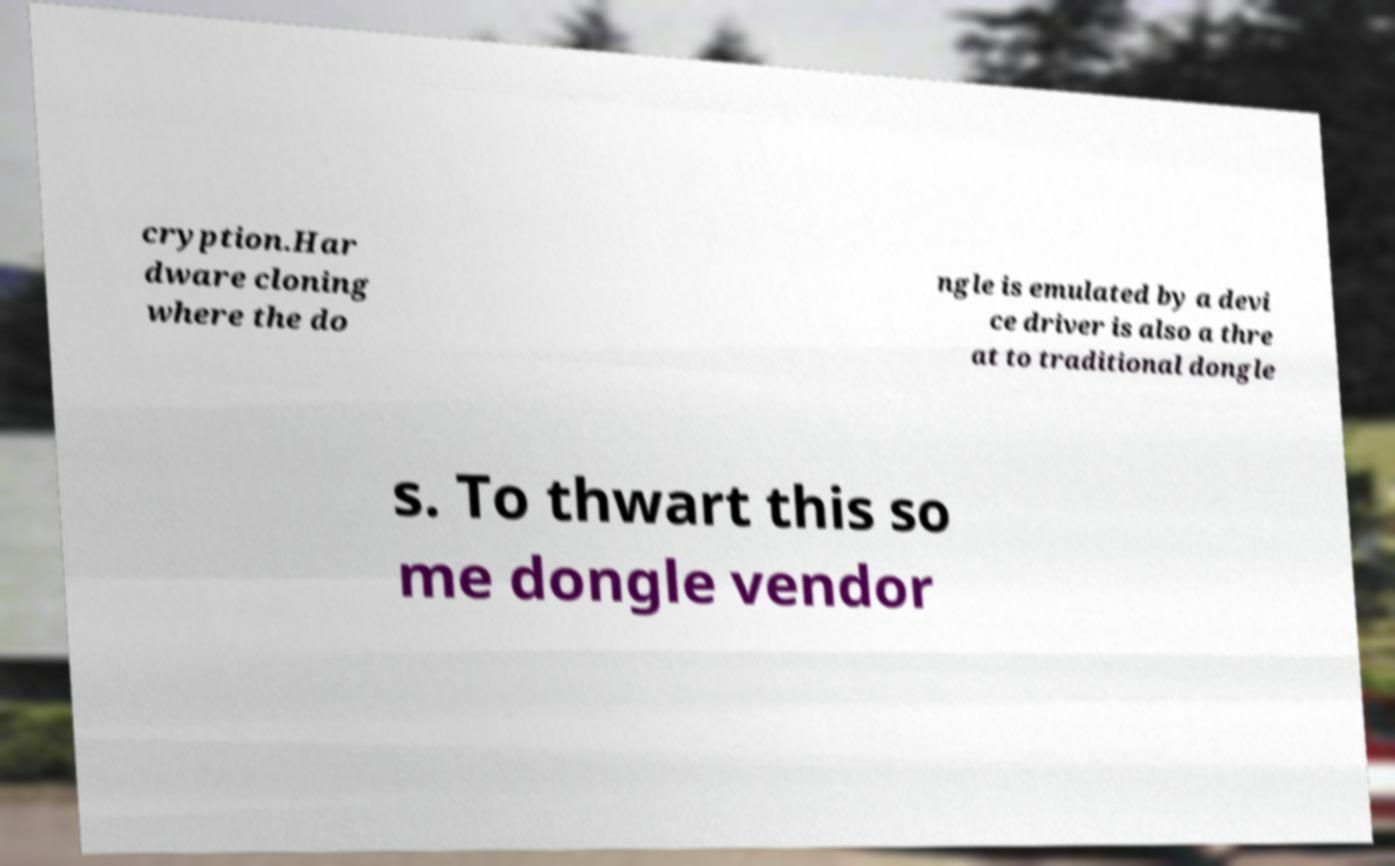Could you extract and type out the text from this image? cryption.Har dware cloning where the do ngle is emulated by a devi ce driver is also a thre at to traditional dongle s. To thwart this so me dongle vendor 